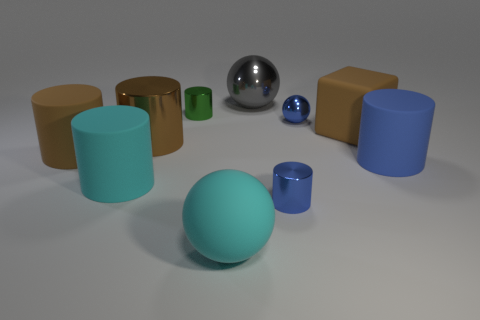What number of big matte things have the same color as the block?
Your response must be concise. 1. What number of objects are either big things or large balls in front of the large blue rubber thing?
Offer a terse response. 7. Are there any green rubber objects of the same shape as the large gray thing?
Give a very brief answer. No. How big is the object that is to the left of the big rubber cylinder that is in front of the large blue object?
Keep it short and to the point. Large. Is the color of the cube the same as the tiny ball?
Your answer should be compact. No. What number of rubber objects are gray spheres or cubes?
Provide a short and direct response. 1. How many big rubber cubes are there?
Offer a terse response. 1. Does the big cylinder that is on the right side of the green shiny cylinder have the same material as the cyan object that is on the right side of the brown metallic thing?
Offer a terse response. Yes. There is a large metallic thing that is the same shape as the blue matte thing; what is its color?
Provide a short and direct response. Brown. The brown thing to the right of the large sphere that is to the right of the matte ball is made of what material?
Provide a succinct answer. Rubber. 